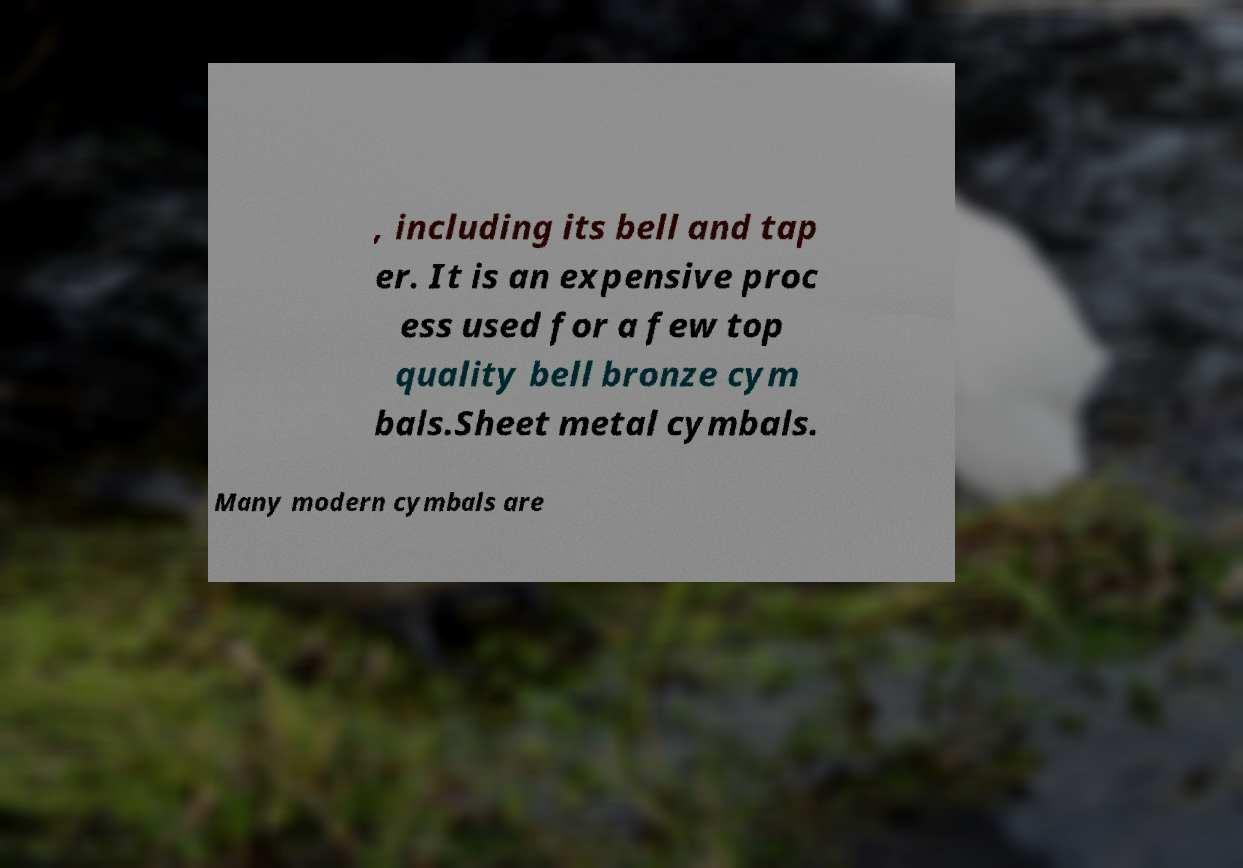Can you accurately transcribe the text from the provided image for me? , including its bell and tap er. It is an expensive proc ess used for a few top quality bell bronze cym bals.Sheet metal cymbals. Many modern cymbals are 